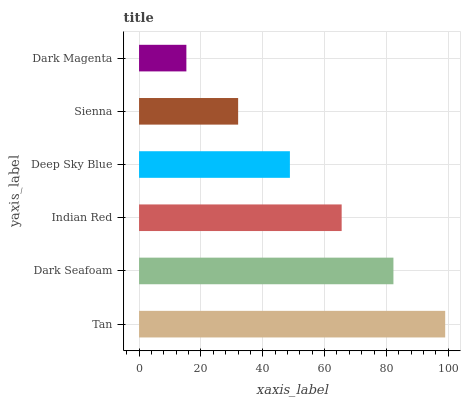Is Dark Magenta the minimum?
Answer yes or no. Yes. Is Tan the maximum?
Answer yes or no. Yes. Is Dark Seafoam the minimum?
Answer yes or no. No. Is Dark Seafoam the maximum?
Answer yes or no. No. Is Tan greater than Dark Seafoam?
Answer yes or no. Yes. Is Dark Seafoam less than Tan?
Answer yes or no. Yes. Is Dark Seafoam greater than Tan?
Answer yes or no. No. Is Tan less than Dark Seafoam?
Answer yes or no. No. Is Indian Red the high median?
Answer yes or no. Yes. Is Deep Sky Blue the low median?
Answer yes or no. Yes. Is Dark Seafoam the high median?
Answer yes or no. No. Is Dark Seafoam the low median?
Answer yes or no. No. 